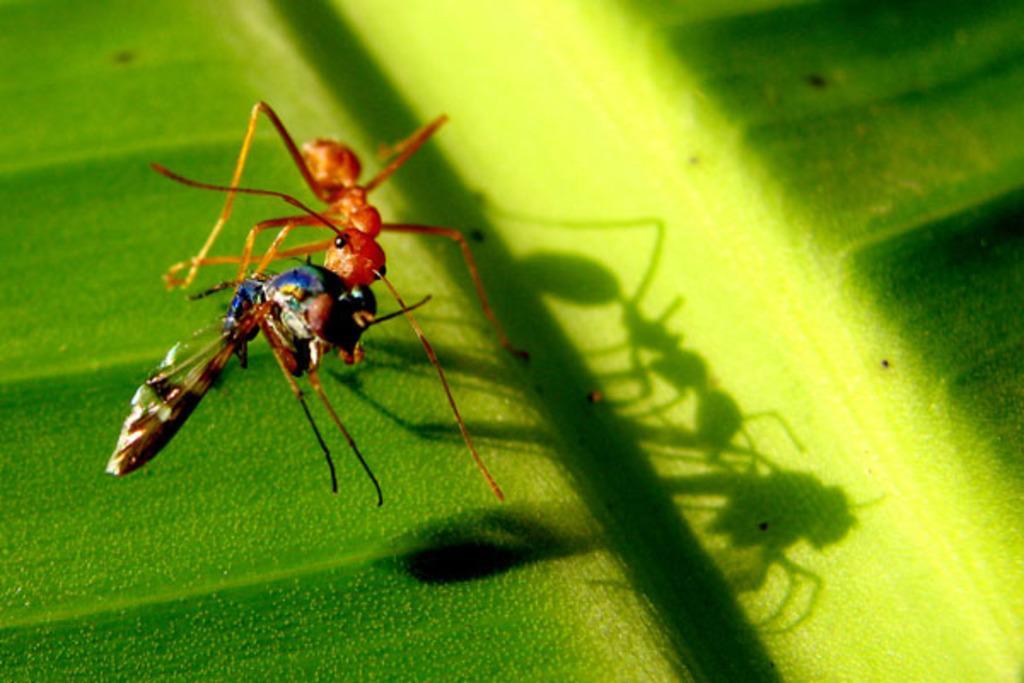Can you describe this image briefly? In this image I see 2 insects on the green color surface. 